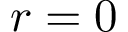Convert formula to latex. <formula><loc_0><loc_0><loc_500><loc_500>r = 0</formula> 